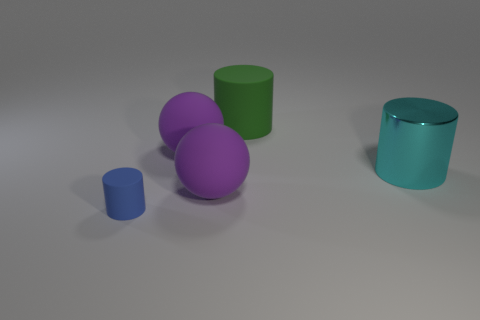Add 3 large brown metallic things. How many objects exist? 8 Subtract 1 spheres. How many spheres are left? 1 Subtract all balls. How many objects are left? 3 Subtract all yellow cylinders. Subtract all gray blocks. How many cylinders are left? 3 Subtract all small green shiny cubes. Subtract all green matte cylinders. How many objects are left? 4 Add 5 big purple spheres. How many big purple spheres are left? 7 Add 3 tiny purple metal things. How many tiny purple metal things exist? 3 Subtract 0 red balls. How many objects are left? 5 